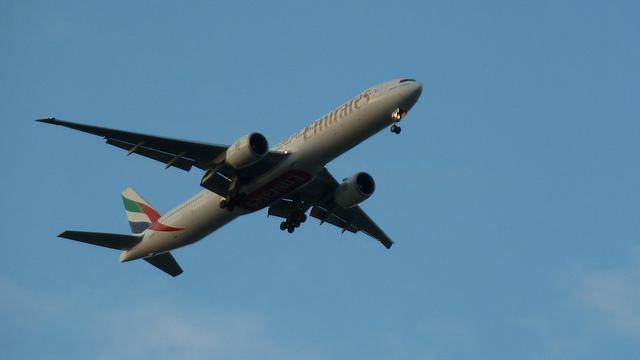How many planes are there?
Give a very brief answer. 1. 